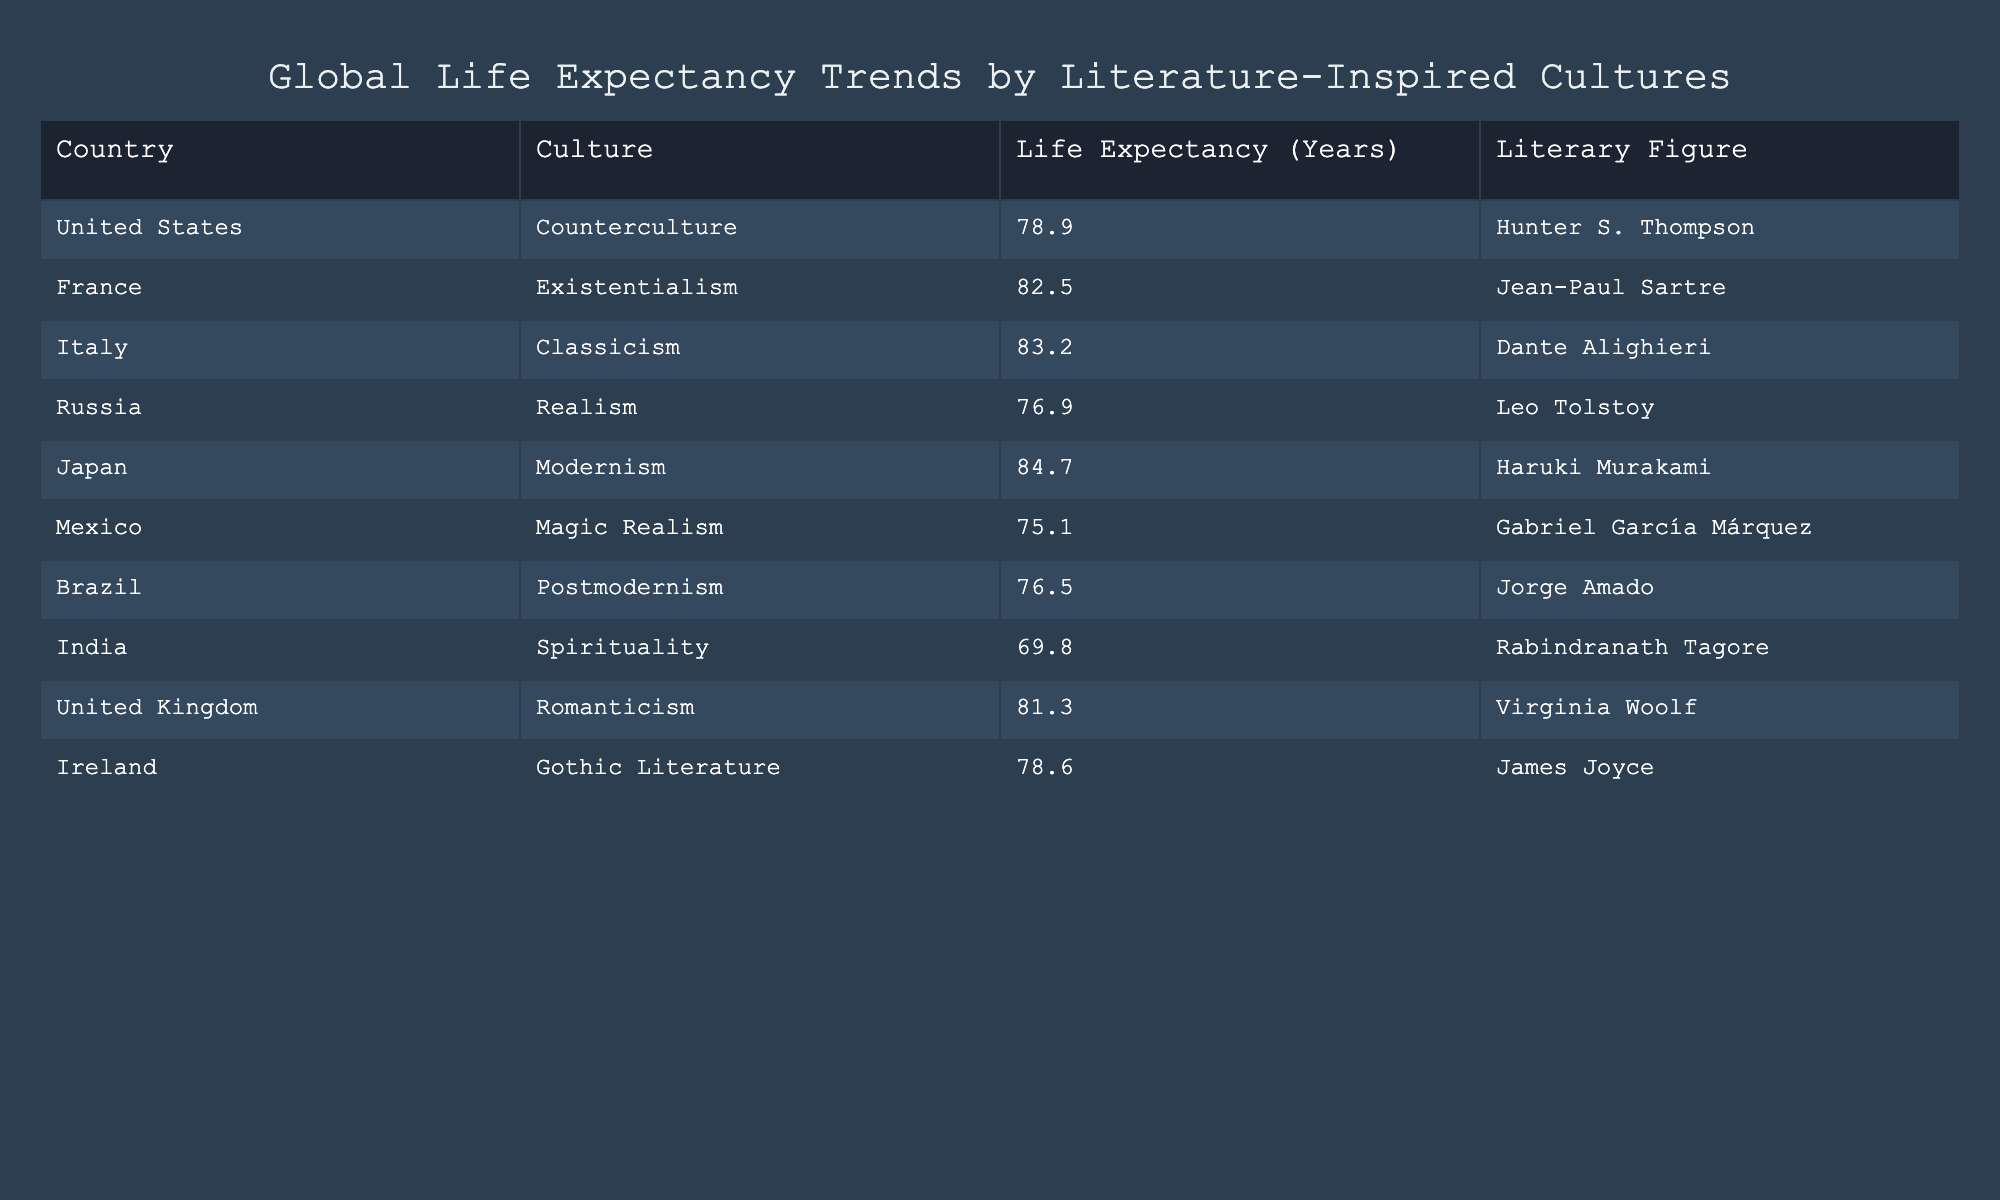What is the life expectancy in Japan? From the table, we find that Japan has a life expectancy listed as 84.7 years.
Answer: 84.7 Which country has the lowest life expectancy? By reviewing the life expectancy values in the table, Mexico has the lowest value at 75.1 years.
Answer: Mexico Is the life expectancy in the United Kingdom higher than that in France? The life expectancy in the United Kingdom is 81.3 years, while in France, it is 82.5 years, which means the life expectancy in the UK is not higher than in France.
Answer: No What is the average life expectancy of the countries listed in the table? To find the average, sum the life expectancy values for all ten countries (78.9 + 82.5 + 83.2 + 76.9 + 84.7 + 75.1 + 76.5 + 69.8 + 81.3 + 78.6), which equals  785.5, then divide by the number of countries (10), resulting in an average of 78.55 years.
Answer: 78.55 Which literary figure is associated with India? Looking at the table, Rabindranath Tagore is the literary figure associated with India.
Answer: Rabindranath Tagore 